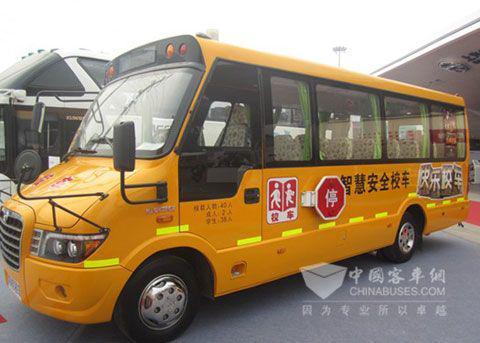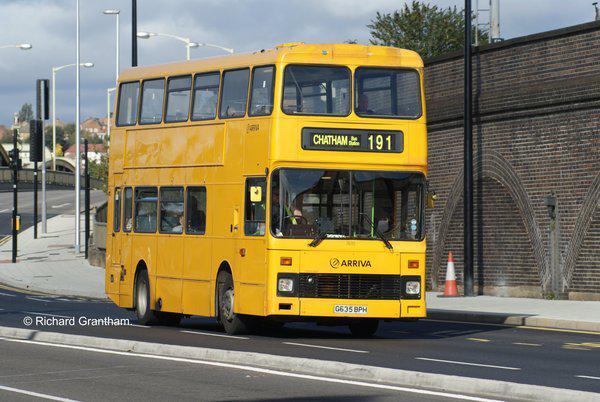The first image is the image on the left, the second image is the image on the right. Examine the images to the left and right. Is the description "At least 3 school buses are parked side by side in one of the pictures." accurate? Answer yes or no. No. The first image is the image on the left, the second image is the image on the right. Given the left and right images, does the statement "Yellow school buses are lined up side by side and facing forward in one of the images." hold true? Answer yes or no. No. 